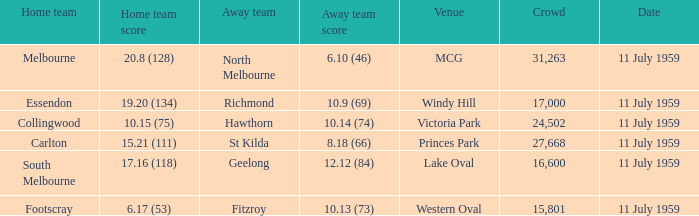How many points does footscray accumulate as the host team? 6.17 (53). 